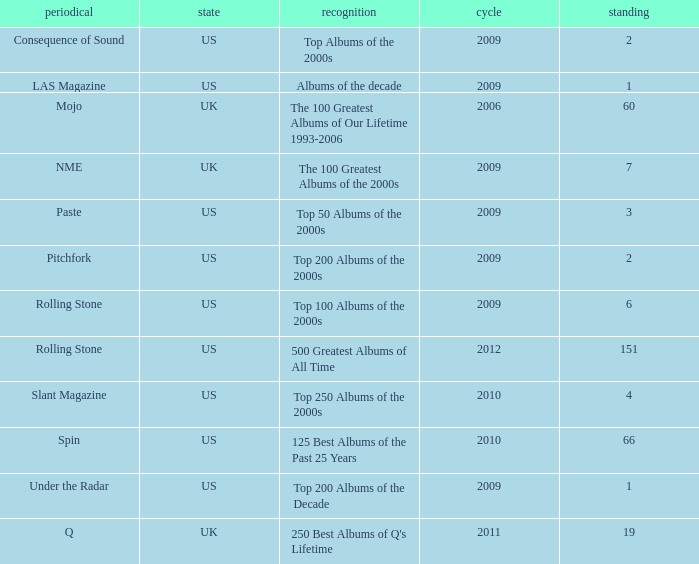What country had a paste publication in 2009? US. 